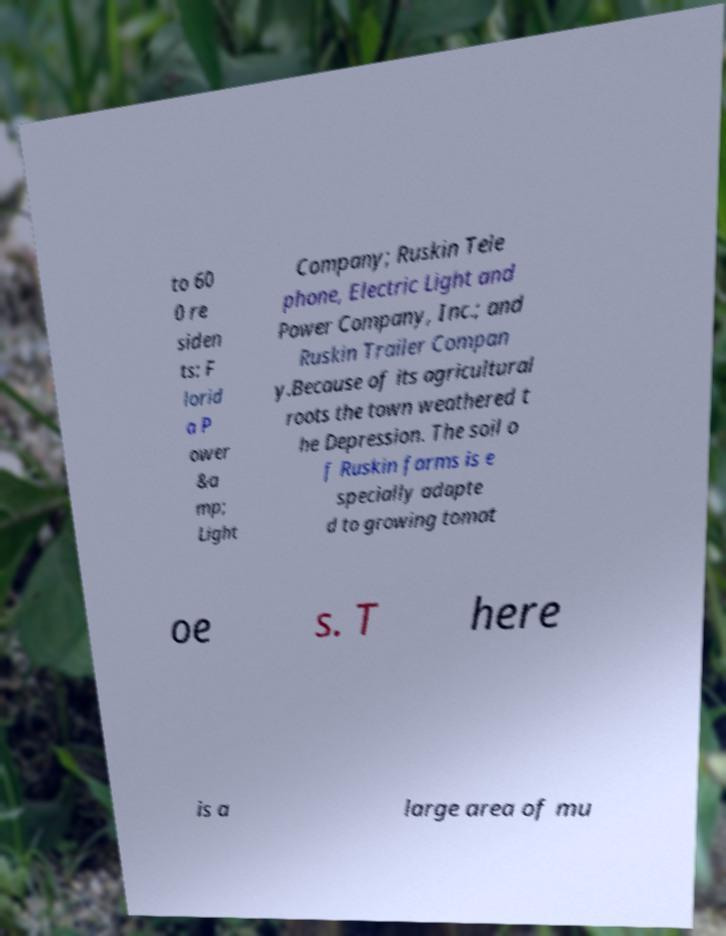For documentation purposes, I need the text within this image transcribed. Could you provide that? to 60 0 re siden ts: F lorid a P ower &a mp; Light Company; Ruskin Tele phone, Electric Light and Power Company, Inc.; and Ruskin Trailer Compan y.Because of its agricultural roots the town weathered t he Depression. The soil o f Ruskin farms is e specially adapte d to growing tomat oe s. T here is a large area of mu 